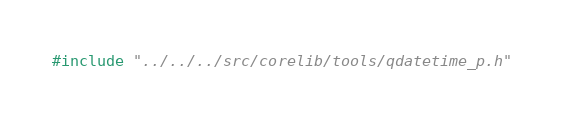Convert code to text. <code><loc_0><loc_0><loc_500><loc_500><_C_>#include "../../../src/corelib/tools/qdatetime_p.h"
</code> 